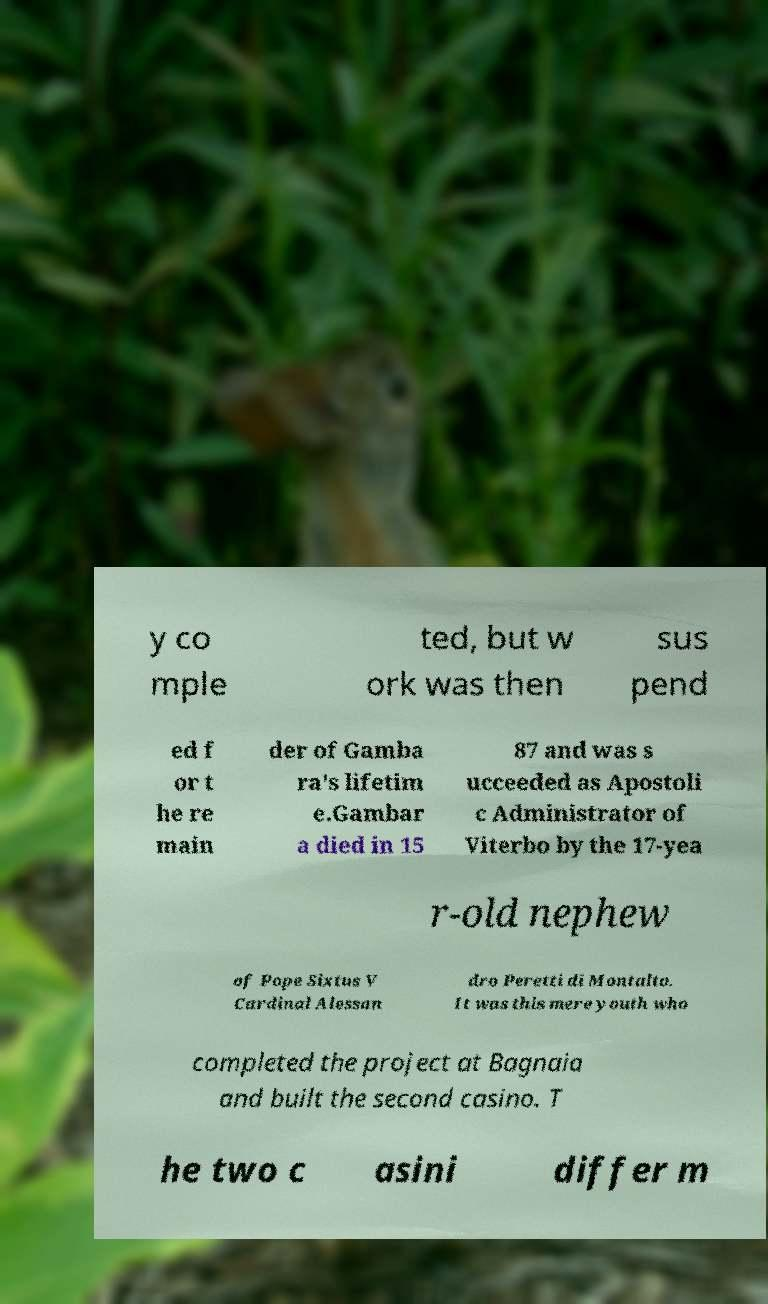Can you accurately transcribe the text from the provided image for me? y co mple ted, but w ork was then sus pend ed f or t he re main der of Gamba ra's lifetim e.Gambar a died in 15 87 and was s ucceeded as Apostoli c Administrator of Viterbo by the 17-yea r-old nephew of Pope Sixtus V Cardinal Alessan dro Peretti di Montalto. It was this mere youth who completed the project at Bagnaia and built the second casino. T he two c asini differ m 